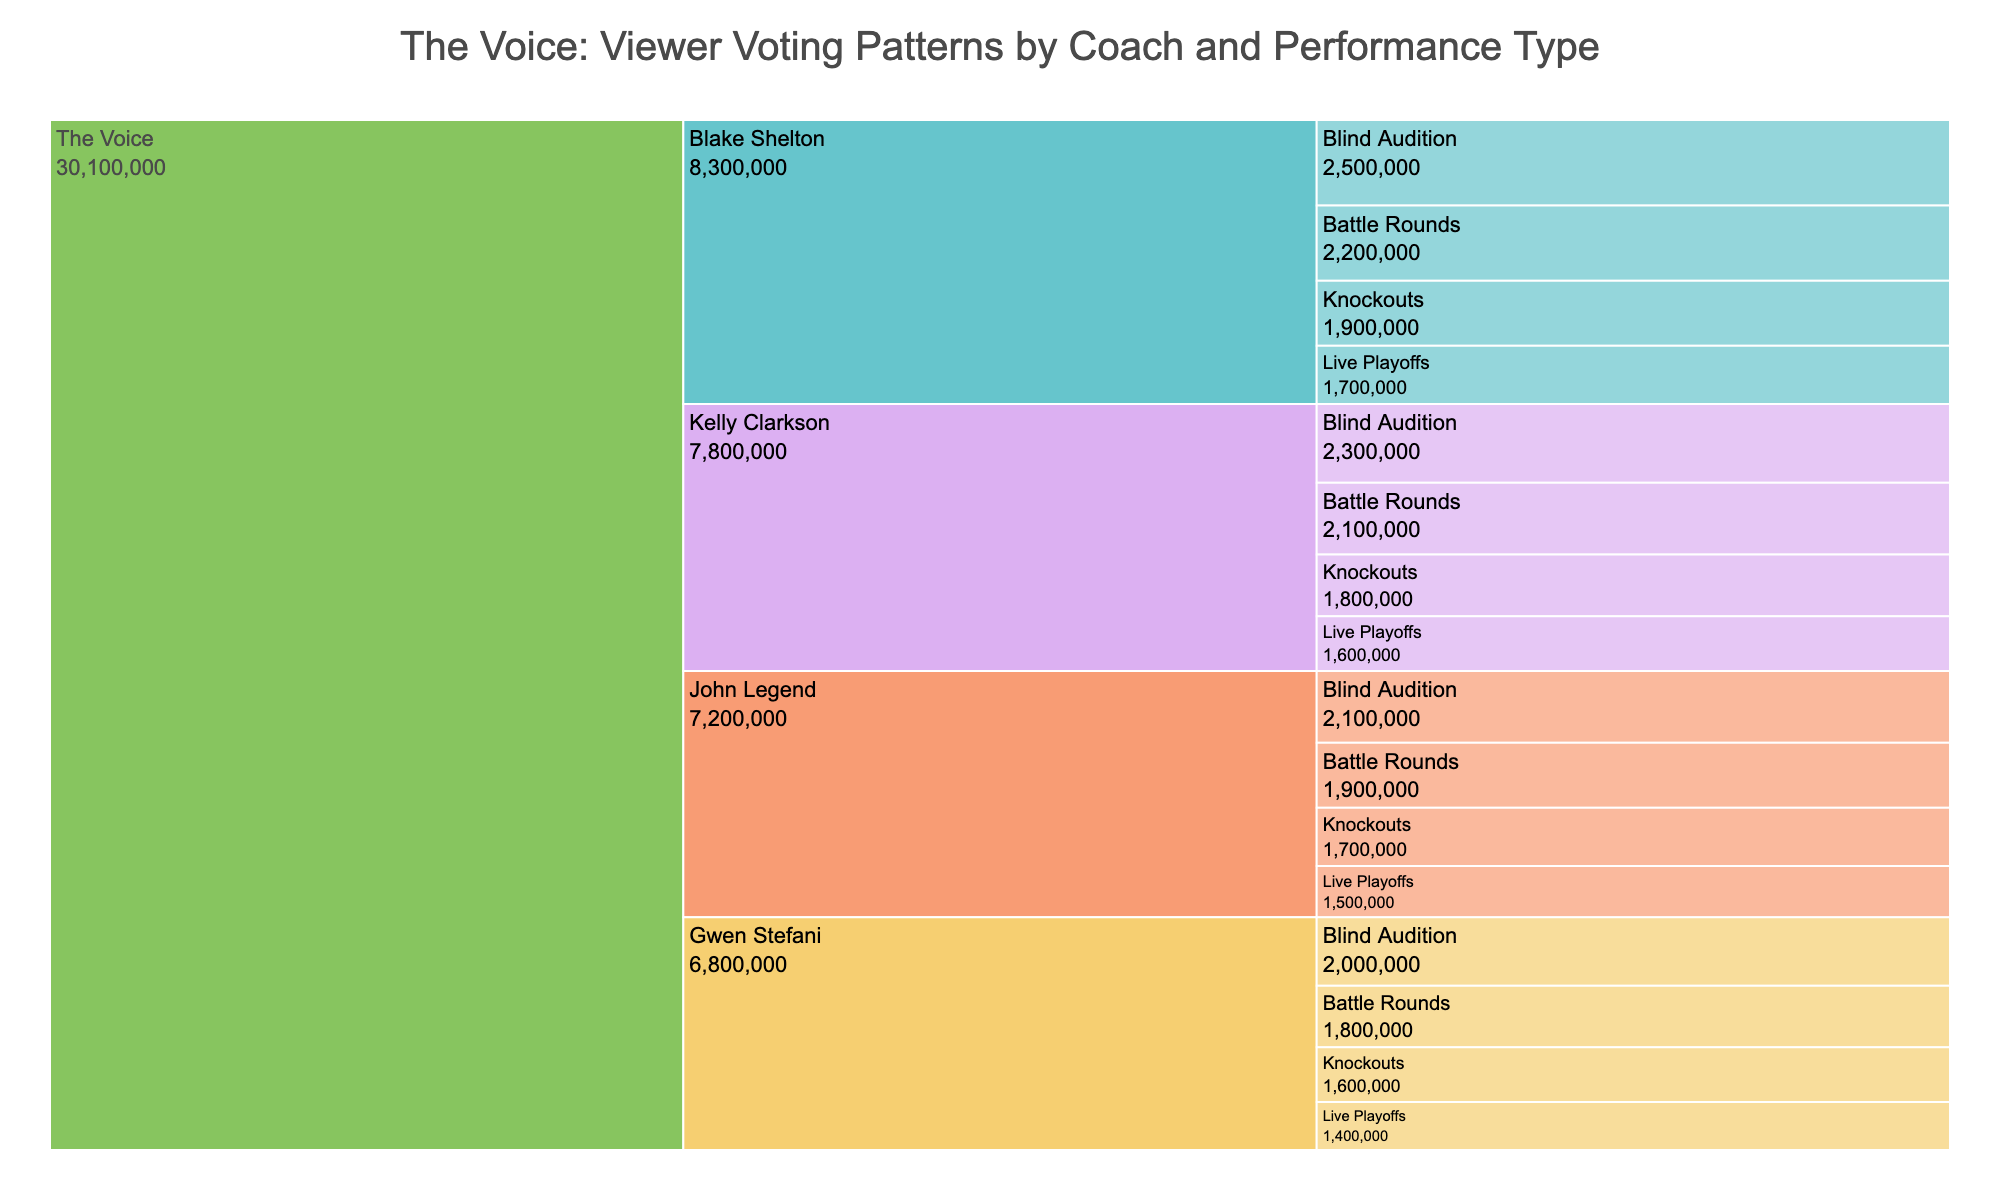What is the title of the Icicle Chart? The title is written at the top center of the figure, indicating the theme of the data visualization. It reads, "The Voice: Viewer Voting Patterns by Coach and Performance Type"
Answer: The Voice: Viewer Voting Patterns by Coach and Performance Type Which coach received the highest number of votes during Blind Auditions? By examining the branches under "Blind Auditions", look for the one with the largest value. Blake Shelton received 2,500,000 votes, the highest in this category
Answer: Blake Shelton How many total votes did Kelly Clarkson's team receive over all performance types? Sum the votes from Kelly Clarkson's Blind Audition (2,300,000), Battle Rounds (2,100,000), Knockouts (1,800,000), and Live Playoffs (1,600,000). The total is 2,300,000 + 2,100,000 + 1,800,000 + 1,600,000 = 7,800,000
Answer: 7,800,000 Who received fewer votes during the Live Playoffs, John Legend or Gwen Stefani? Compare the votes under "Live Playoffs" for both John Legend and Gwen Stefani. John Legend received 1,500,000 votes, and Gwen Stefani received 1,400,000 votes. Therefore, Gwen Stefani received fewer votes
Answer: Gwen Stefani Which performance type garnered the most total votes across all coaches? Sum the votes for each performance type across all coaches and compare. Blind Auditions: 2,500,000 + 2,300,000 + 2,100,000 + 2,000,000 = 8,900,000; Battle Rounds: 2,200,000 + 2,100,000 + 1,900,000 + 1,800,000 = 8,000,000; Knockouts: 1,900,000 + 1,800,000 + 1,700,000 + 1,600,000 = 7,000,000; Live Playoffs: 1,700,000 + 1,600,000 + 1,500,000 + 1,400,000 = 6,200,000. Blind Auditions have the highest total
Answer: Blind Auditions Which coach had the most consistent voting numbers across different performance types? Consistency can be assessed by observing the differences in votes across the performance types for each coach. Blake Shelton's votes range from 2,500,000 to 1,700,000; Kelly Clarkson: 2,300,000 to 1,600,000; John Legend: 2,100,000 to 1,500,000; Gwen Stefani: 2,000,000 to 1,400,000. Kelly Clarkson shows the smallest range, indicating most consistency
Answer: Kelly Clarkson How does Gwen Stefani's total votes compare to John Legend's? First, sum the votes for each coach. Gwen Stefani: 2,000,000 + 1,800,000 + 1,600,000 + 1,400,000 = 6,800,000; John Legend: 2,100,000 + 1,900,000 + 1,700,000 + 1,500,000 = 7,200,000. John Legend has more total votes than Gwen Stefani
Answer: John Legend has more votes What is the difference in votes between the highest and the lowest voting performance type for Blake Shelton? Identify Blake Shelton's highest vote count (Blind Audition - 2,500,000) and lowest vote count (Live Playoffs - 1,700,000). The difference is 2,500,000 - 1,700,000 = 800,000
Answer: 800,000 